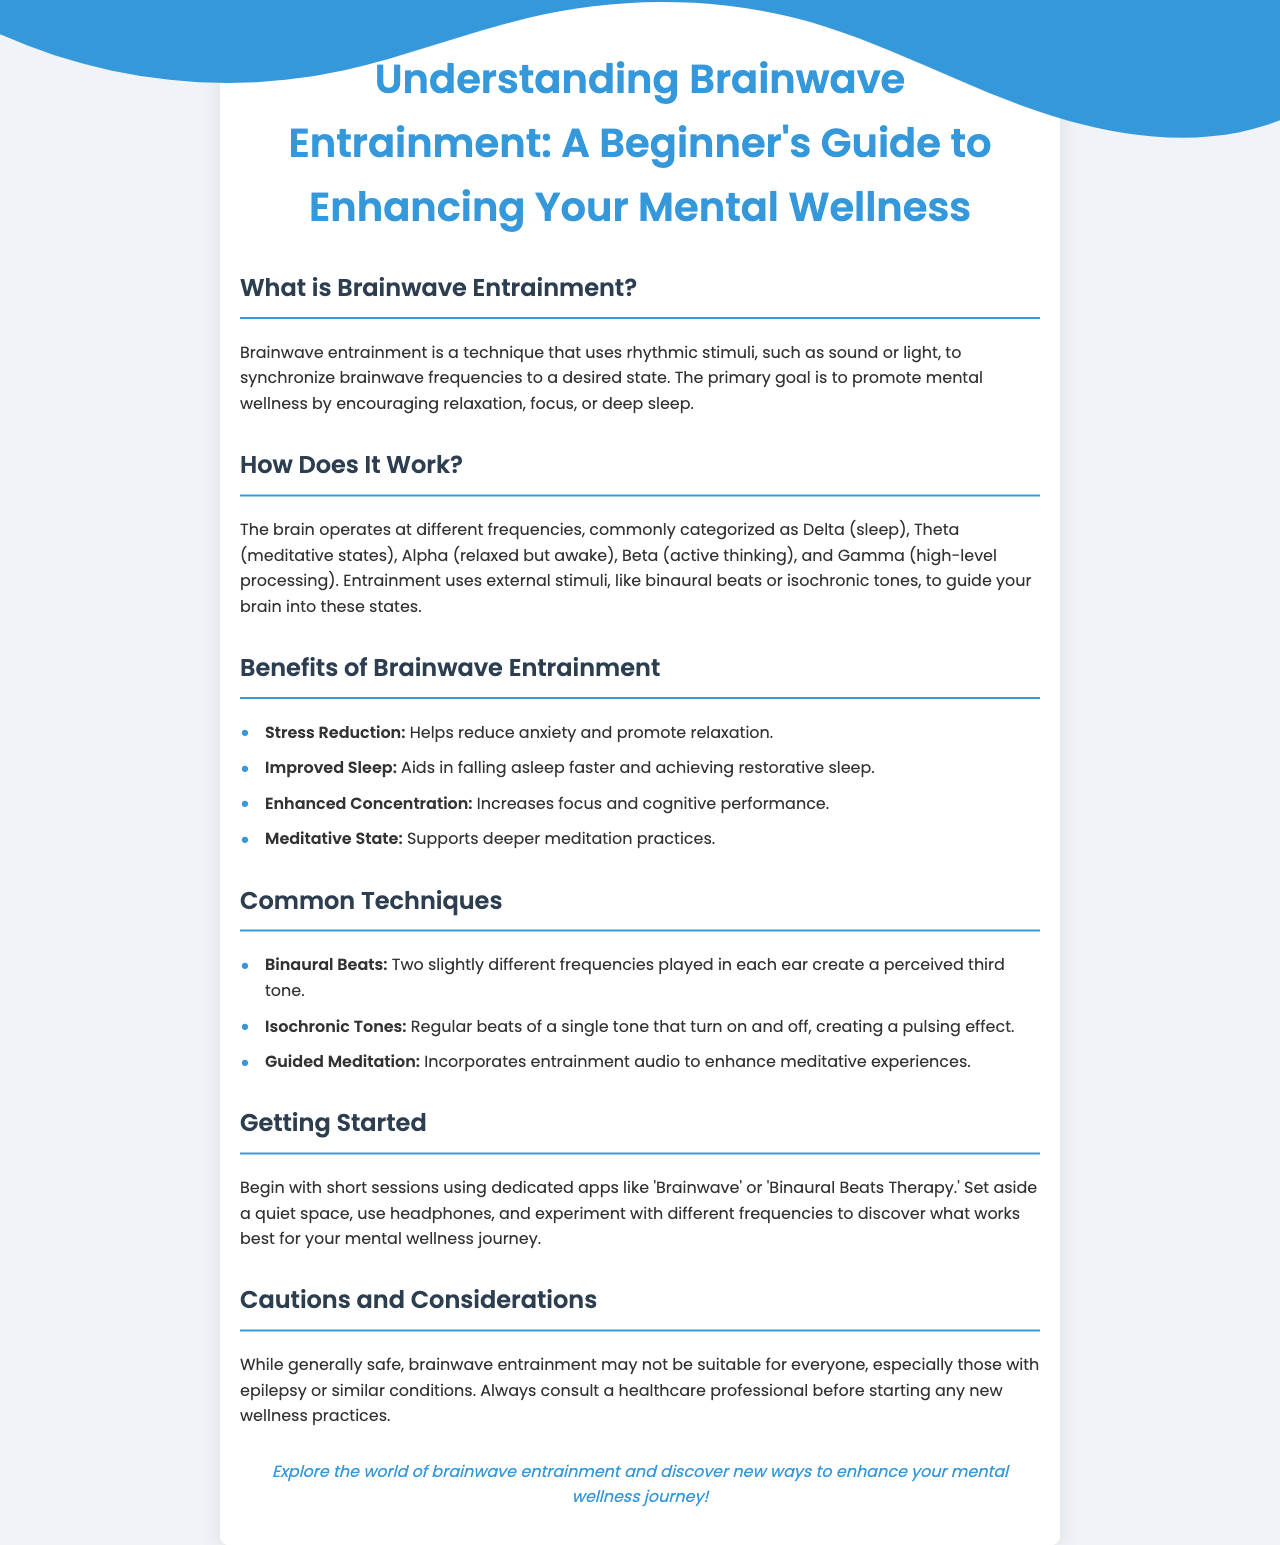What is brainwave entrainment? Brainwave entrainment is a technique that uses rhythmic stimuli to synchronize brainwave frequencies to a desired state.
Answer: A technique that uses rhythmic stimuli How many brainwave categories are mentioned? The document lists the brainwave categories Delta, Theta, Alpha, Beta, and Gamma, totaling five categories.
Answer: Five What is a benefit of brainwave entrainment? The document lists benefits such as stress reduction, improved sleep, enhanced concentration, and support for deeper meditation.
Answer: Stress reduction What are binaural beats? Binaural beats are described as two slightly different frequencies played in each ear to create a perceived third tone.
Answer: Two slightly different frequencies What is the recommended starting point for beginners? The document suggests beginning with short sessions using dedicated apps such as 'Brainwave' or 'Binaural Beats Therapy.'
Answer: Short sessions using dedicated apps What caution is mentioned regarding brainwave entrainment? It notes that brainwave entrainment may not be suitable for everyone, particularly those with epilepsy or similar conditions.
Answer: Epilepsy How does brainwave entrainment promote mental wellness? The primary goal is to promote mental wellness by encouraging relaxation, focus, or deep sleep.
Answer: By encouraging relaxation, focus, or deep sleep What type of tones are isochronic tones? Isochronic tones are regular beats of a single tone that turn on and off, creating a pulsing effect.
Answer: Regular beats of a single tone 